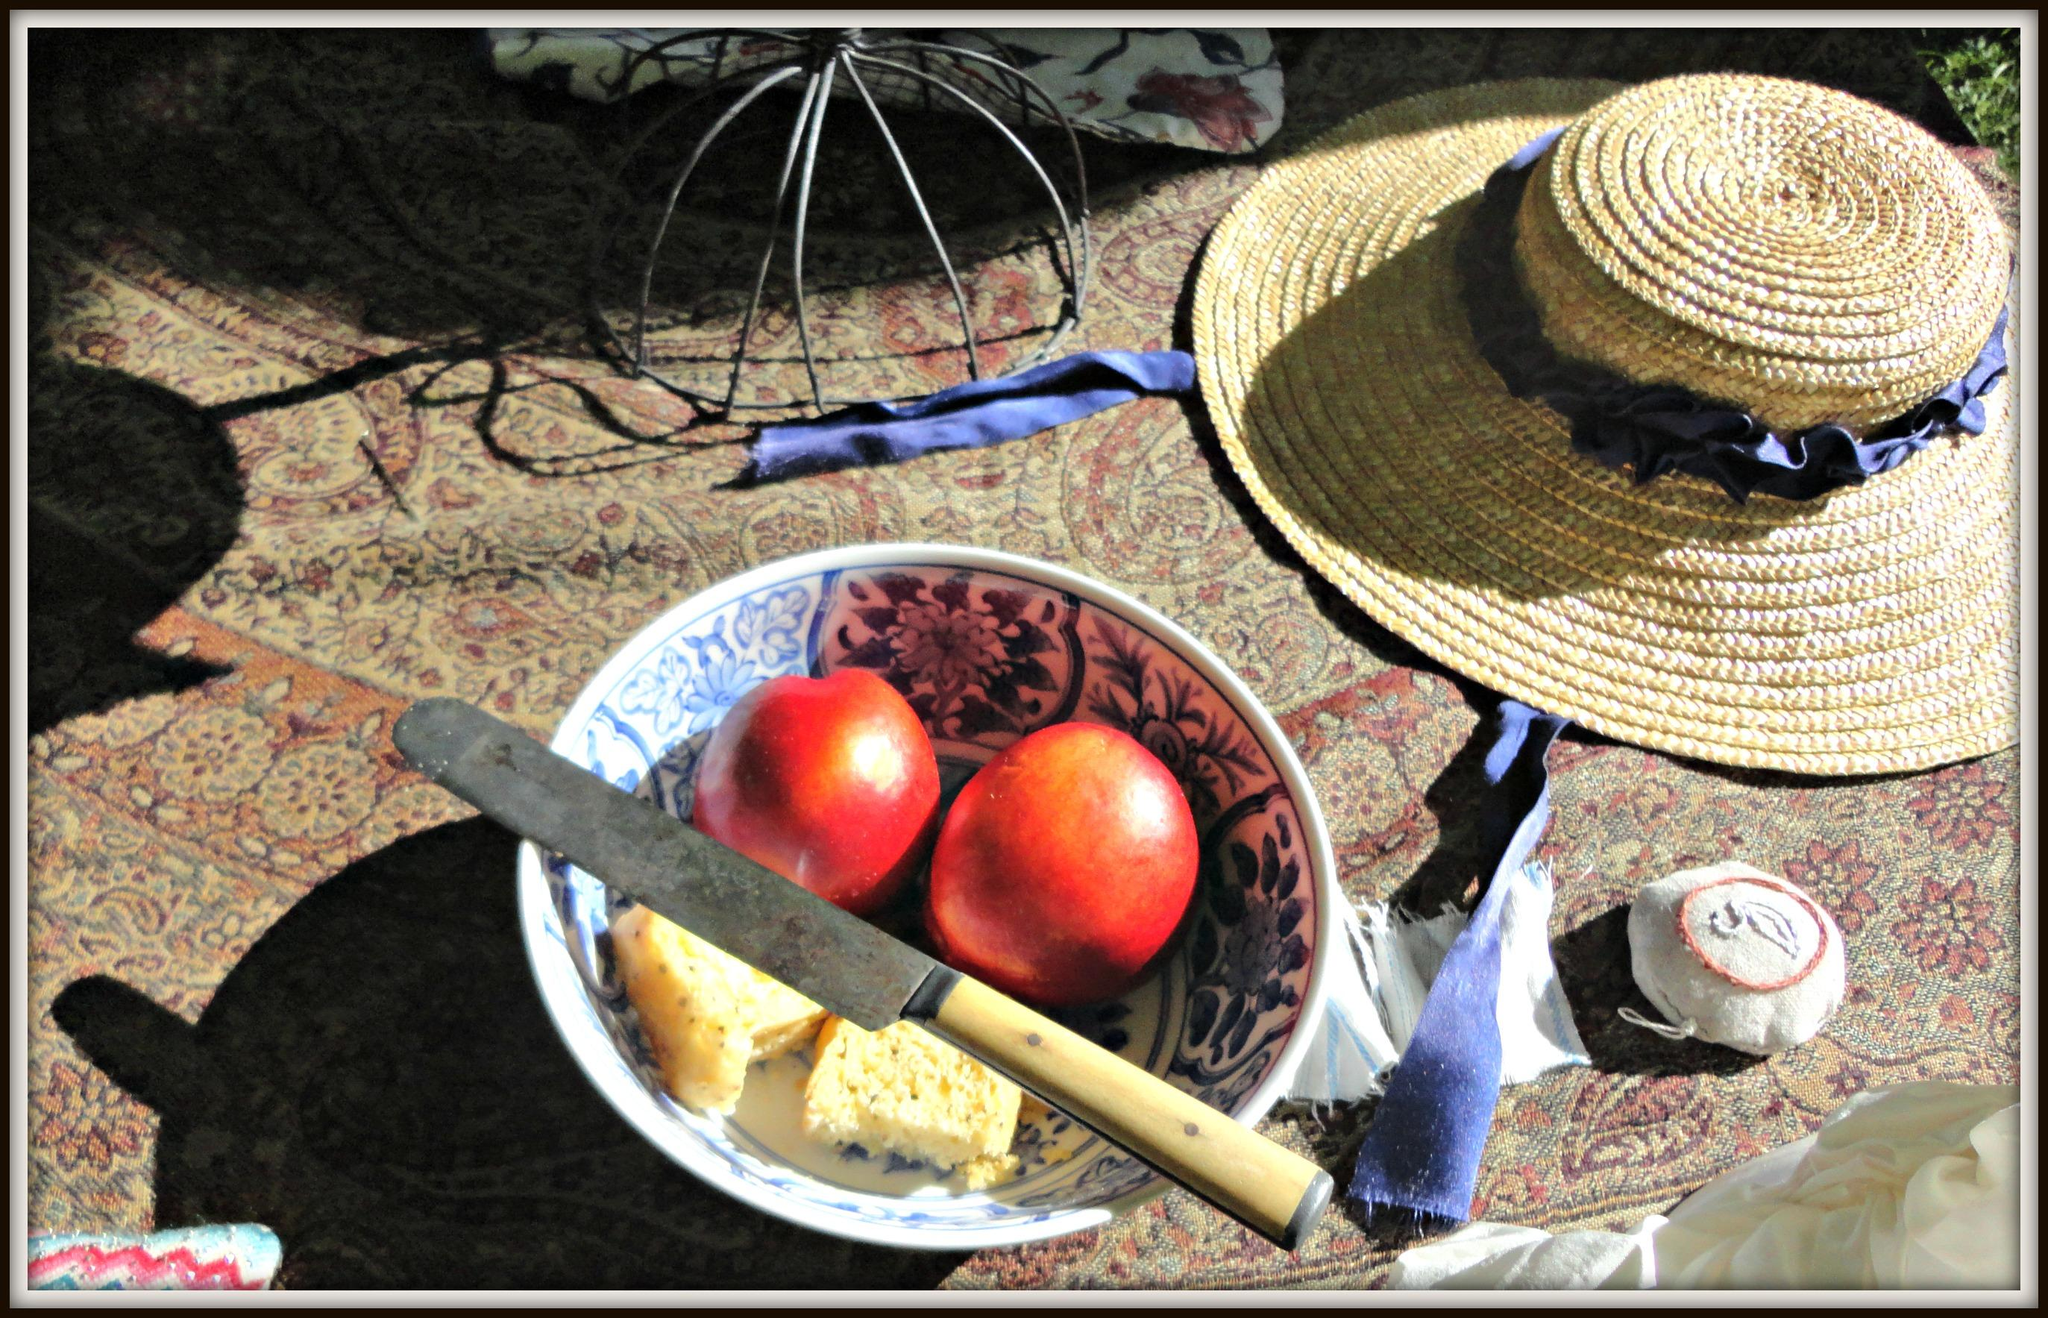What type of food can be seen in the image? There are fruits and other food items in the image. How are the food items arranged in the image? The food items are in a bowl in the image. What is the color of the bowl? The bowl is white in color. What utensil is present in the image? There is a knife in the image. What can be seen in the background of the image? There is a cream-colored cap in the background of the image. What is the title of the book that is being read by the person in the image? There is no person or book present in the image; it only contains food items in a bowl. 